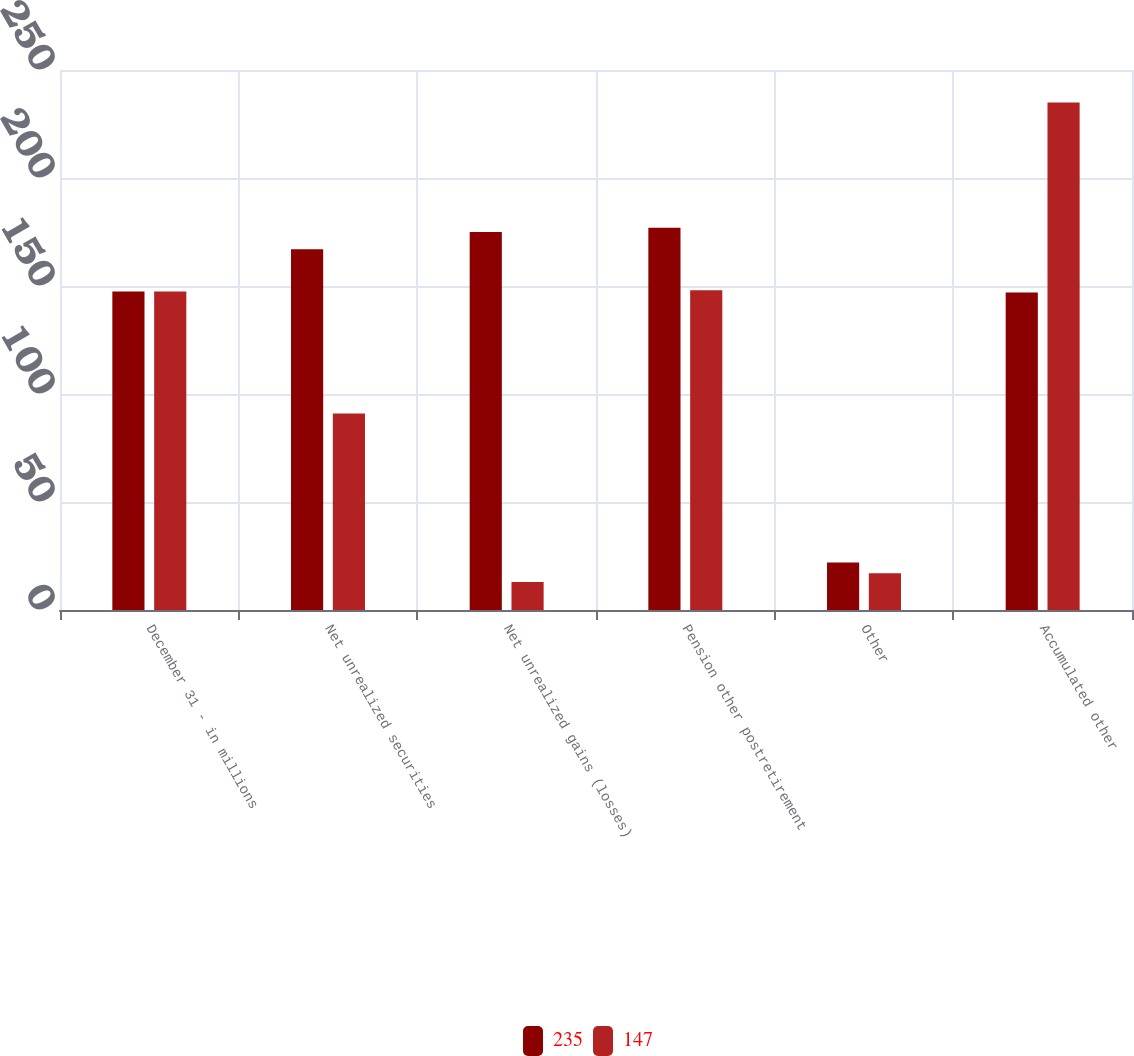Convert chart. <chart><loc_0><loc_0><loc_500><loc_500><stacked_bar_chart><ecel><fcel>December 31 - in millions<fcel>Net unrealized securities<fcel>Net unrealized gains (losses)<fcel>Pension other postretirement<fcel>Other<fcel>Accumulated other<nl><fcel>235<fcel>147.5<fcel>167<fcel>175<fcel>177<fcel>22<fcel>147<nl><fcel>147<fcel>147.5<fcel>91<fcel>13<fcel>148<fcel>17<fcel>235<nl></chart> 